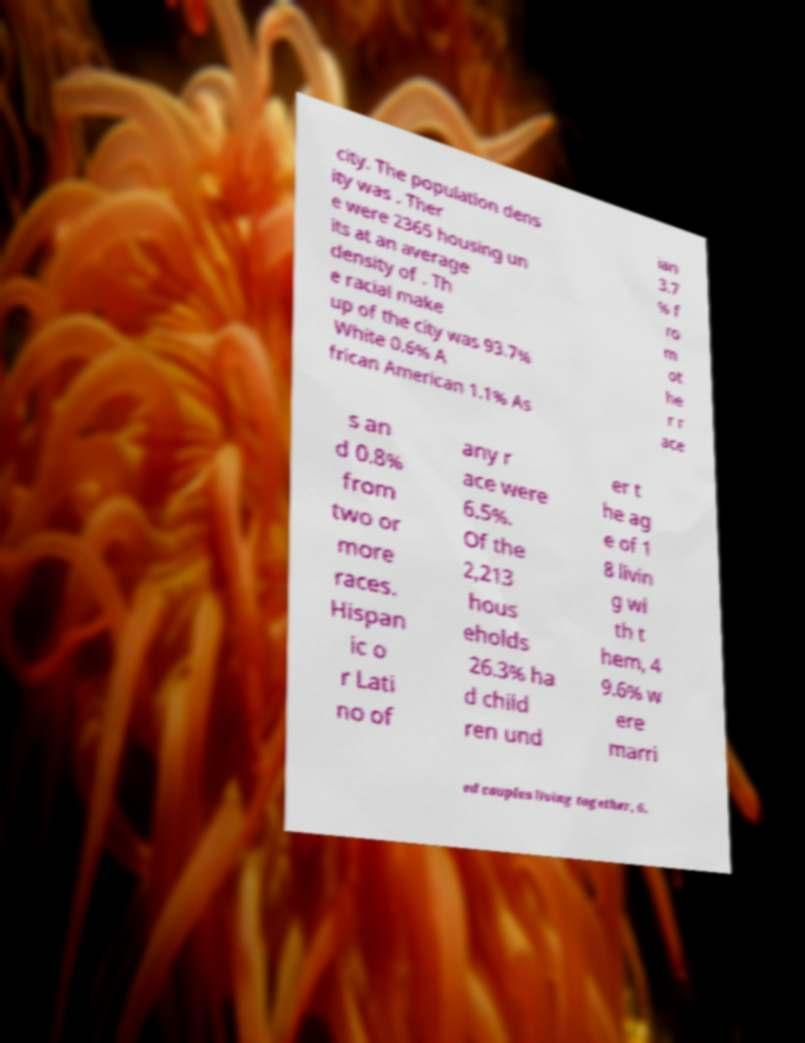I need the written content from this picture converted into text. Can you do that? city. The population dens ity was . Ther e were 2365 housing un its at an average density of . Th e racial make up of the city was 93.7% White 0.6% A frican American 1.1% As ian 3.7 % f ro m ot he r r ace s an d 0.8% from two or more races. Hispan ic o r Lati no of any r ace were 6.5%. Of the 2,213 hous eholds 26.3% ha d child ren und er t he ag e of 1 8 livin g wi th t hem, 4 9.6% w ere marri ed couples living together, 6. 